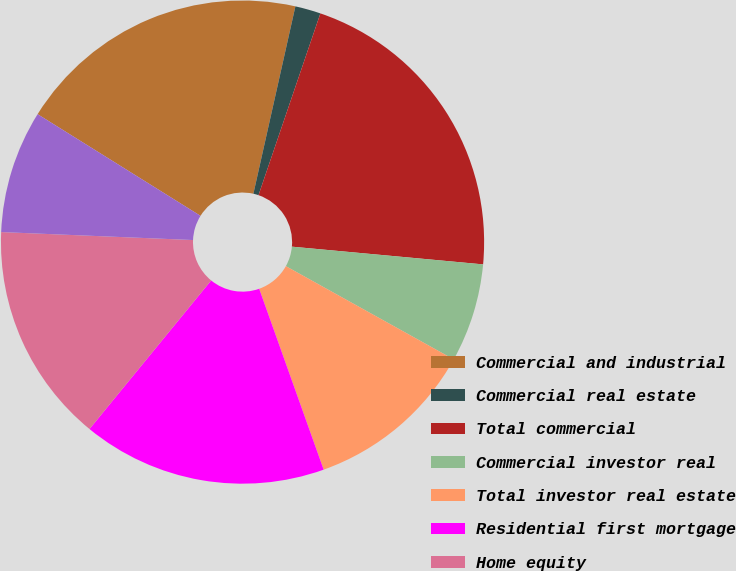Convert chart. <chart><loc_0><loc_0><loc_500><loc_500><pie_chart><fcel>Commercial and industrial<fcel>Commercial real estate<fcel>Total commercial<fcel>Commercial investor real<fcel>Total investor real estate<fcel>Residential first mortgage<fcel>Home equity<fcel>Indirect-vehicles<nl><fcel>19.63%<fcel>1.71%<fcel>21.25%<fcel>6.6%<fcel>11.48%<fcel>16.37%<fcel>14.74%<fcel>8.22%<nl></chart> 